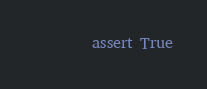<code> <loc_0><loc_0><loc_500><loc_500><_Python_>        assert True
</code> 